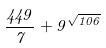Convert formula to latex. <formula><loc_0><loc_0><loc_500><loc_500>\frac { 4 4 9 } { 7 } + 9 ^ { \sqrt { 1 0 6 } }</formula> 